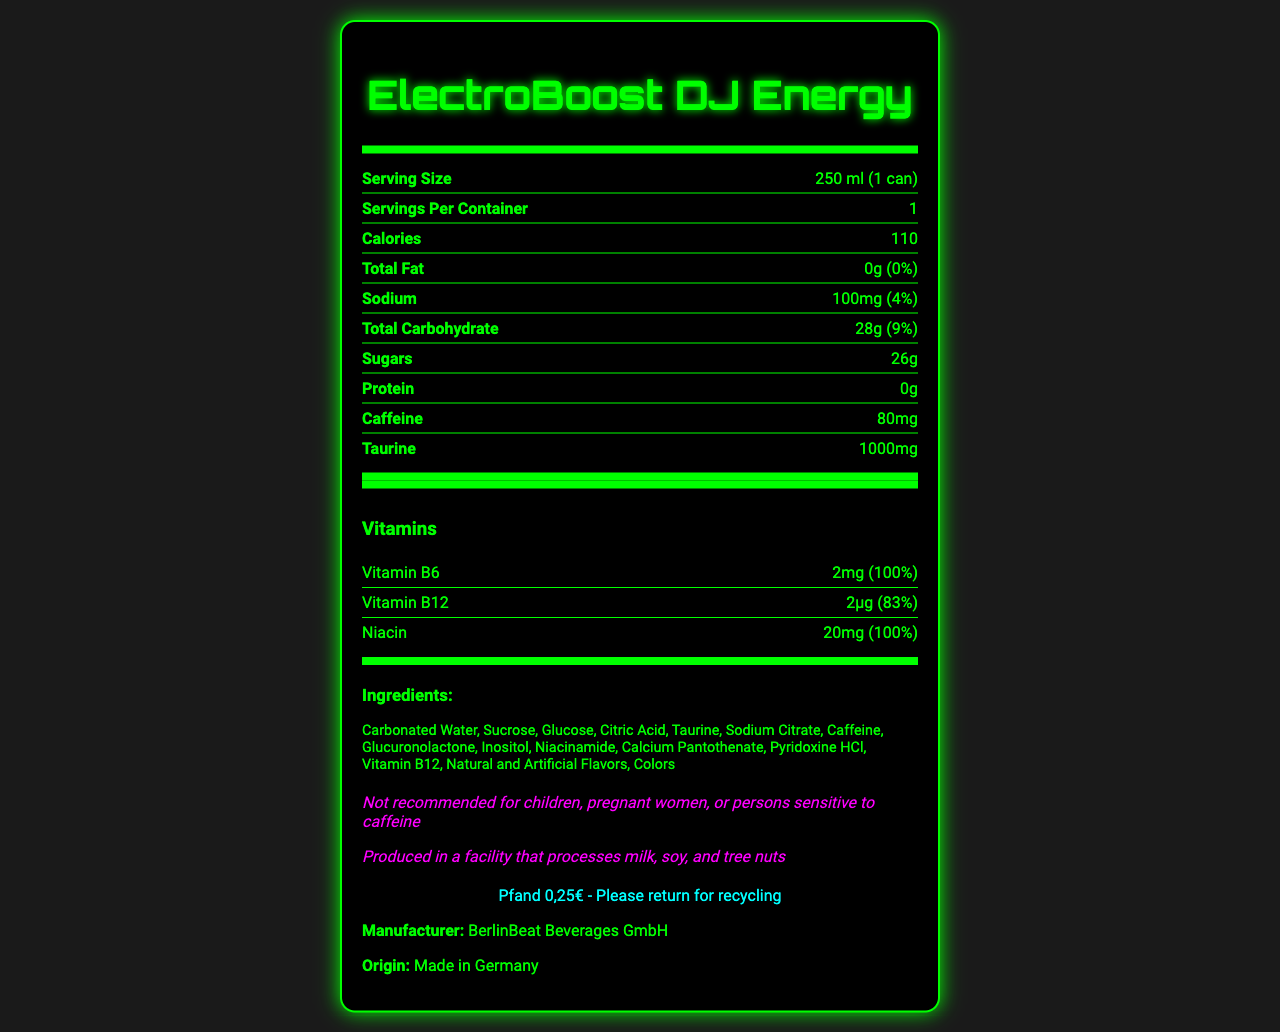what is the serving size of ElectroBoost DJ Energy? The serving size is directly listed as "250 ml (1 can)" in the first section of the document.
Answer: 250 ml (1 can) how many calories are in one can of ElectroBoost DJ Energy? The document states that one can contains 110 calories.
Answer: 110 what is the total amount of sugars in one serving? The sugars amount is provided as 26g in the nutrition facts section.
Answer: 26g which vitamin in ElectroBoost DJ Energy has the highest daily value percentage? The daily value percentage for Vitamin B6 is listed as 100%, which is the highest among the vitamins listed.
Answer: Vitamin B6 name two ingredients found in ElectroBoost DJ Energy. The ingredients section lists Carbonated Water and Sucrose among the ingredients.
Answer: Carbonated Water, Sucrose what is the sodium content and its daily value percentage? A. 200mg (8%) B. 50mg (2%) C. 100mg (4%) The nutrition facts list the sodium content as 100mg with a daily value percentage of 4%.
Answer: C. 100mg (4%) which of the following is not an ingredient in ElectroBoost DJ Energy? A. Taurine B. Inulin C. Citric Acid D. Glucuronolactone Inulin is not listed among the ingredients, while Taurine, Citric Acid, and Glucuronolactone are.
Answer: B. Inulin is ElectroBoost DJ Energy recommended for children or pregnant women? The disclaimer states that the product is not recommended for children, pregnant women, or persons sensitive to caffeine.
Answer: No summarize the main idea of the ElectroBoost DJ Energy Nutrition Facts Label. The document provides detailed nutritional information, ingredients, and additional consumer guidelines for ElectroBoost DJ Energy, highlighting its energy-boosting contents and consumer advisories.
Answer: ElectroBoost DJ Energy is an energy drink with ingredients that boost energy, including caffeine and vitamins. It contains 110 calories per can, with notable amounts of Vitamin B6, Vitamin B12, and Niacin. The drink has a high sugar content (26g) and includes several ingredients commonly found in energy drinks. It is produced in Germany and not recommended for certain people due to its caffeine content. how much caffeine is in one can of ElectroBoost DJ Energy? The document lists the amount of caffeine as 80mg per serving.
Answer: 80mg can the amount of protein in ElectroBoost DJ Energy help build muscles? The protein content is listed as 0g, which means it doesn't contribute to muscle building.
Answer: No what is the recommended recycling action for the can? The recycling information instructs to return the can for recycling.
Answer: Please return for recycling how many servings are in one container of ElectroBoost DJ Energy? The document states that there is 1 serving per container.
Answer: 1 name the manufacturer of ElectroBoost DJ Energy. The manufacturer listed in the document is BerlinBeat Beverages GmbH.
Answer: BerlinBeat Beverages GmbH is there a risk of allergen contamination in ElectroBoost DJ Energy? The document notes that the product is produced in a facility that processes milk, soy, and tree nuts.
Answer: Yes is the origin of ElectoBoost DJ Energy specified? The document states that ElectroBoost DJ Energy is made in Germany.
Answer: Yes does ElectroBoost DJ Energy contain any artificial flavors? The ingredients list includes "Natural and Artificial Flavors," indicating the presence of artificial flavors.
Answer: Yes what is the daily value percentage of Niacin provided by ElectroBoost DJ Energy? The nutrition facts list the daily value percentage of Niacin as 100%.
Answer: 100% is Glucuronolactone an ingredient in ElectroBoost DJ Energy? The ingredients section includes Glucuronolactone.
Answer: Yes which vitamin has the lowest daily value percentage in ElectroBoost DJ Energy? Vitamin B12 has a daily value percentage of 83%, which is lower than the daily value percentages of Vitamin B6 and Niacin.
Answer: Vitamin B12 how much taurine is in one can of ElectroBoost DJ Energy? The document lists the amount of taurine as 1000mg per serving.
Answer: 1000mg what is the advantage of consuming vitamins like B6 and B12 found in ElectroBoost DJ Energy? The document does not provide details on the specific benefits of consuming these vitamins.
Answer: Not enough information 